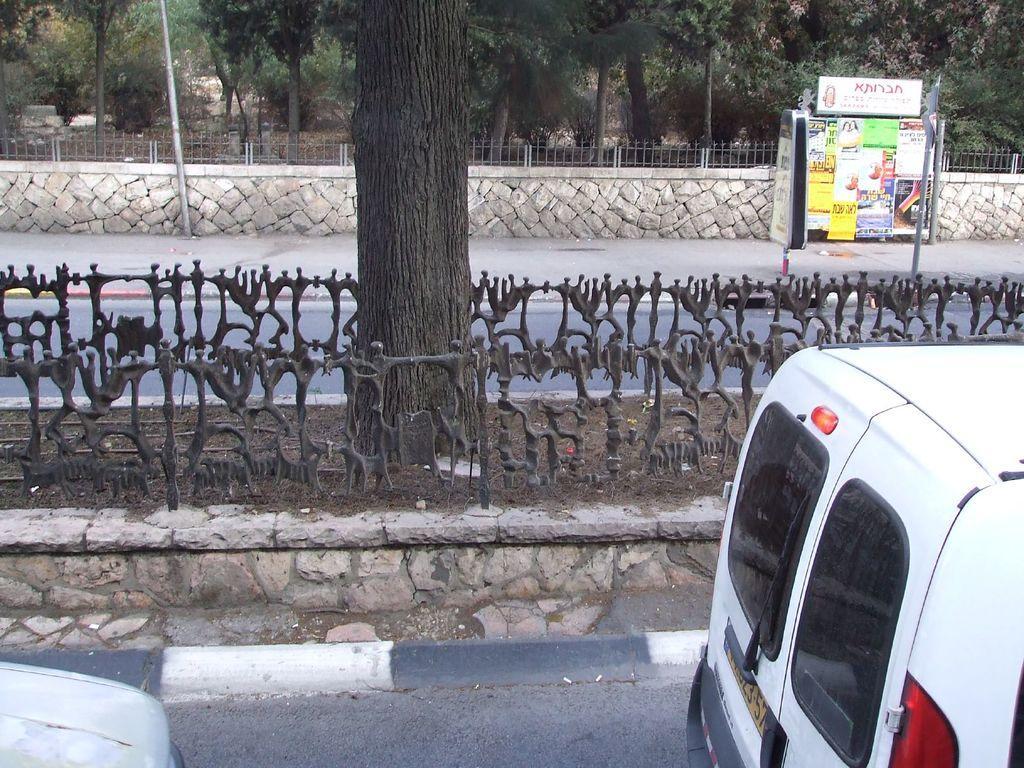How would you summarize this image in a sentence or two? In this picture we can see vehicles on the road, fences, poles, posters and in the background we can see trees. 